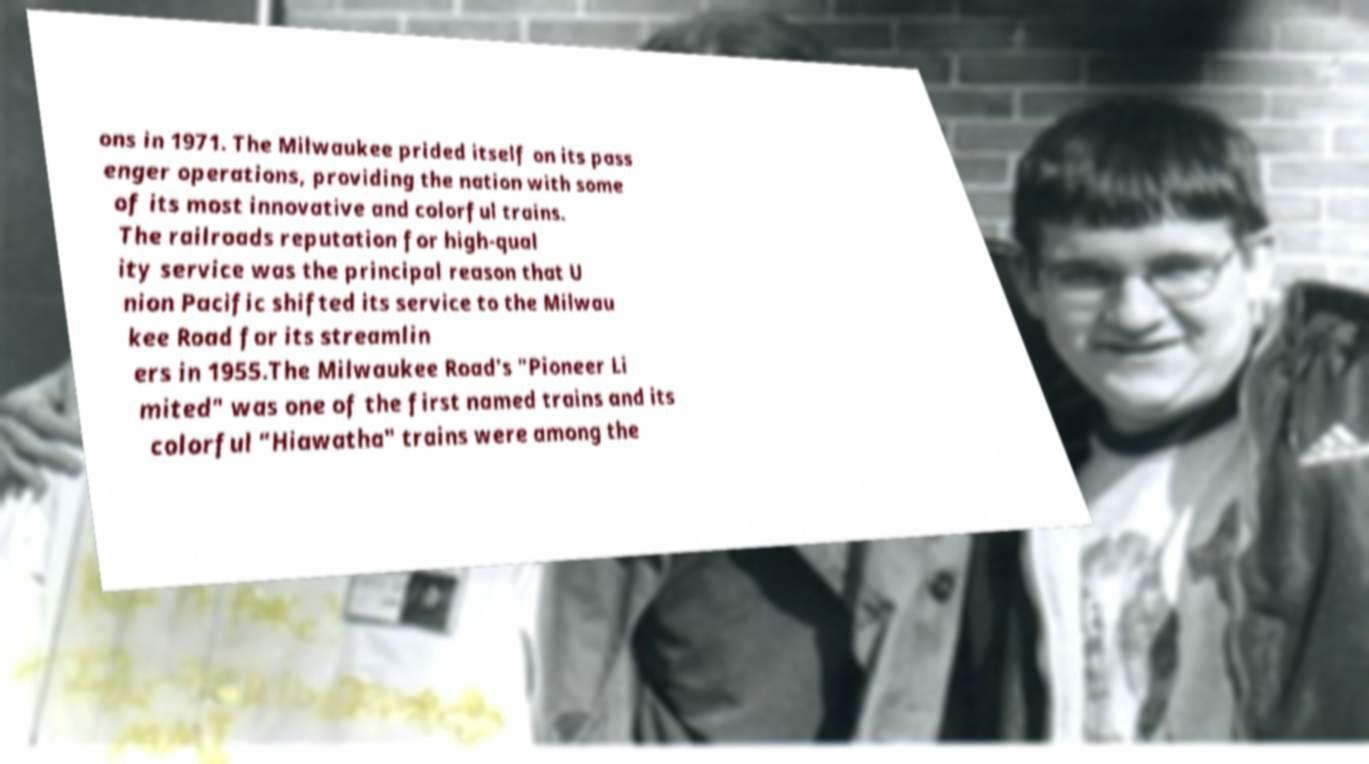Please identify and transcribe the text found in this image. ons in 1971. The Milwaukee prided itself on its pass enger operations, providing the nation with some of its most innovative and colorful trains. The railroads reputation for high-qual ity service was the principal reason that U nion Pacific shifted its service to the Milwau kee Road for its streamlin ers in 1955.The Milwaukee Road's "Pioneer Li mited" was one of the first named trains and its colorful "Hiawatha" trains were among the 